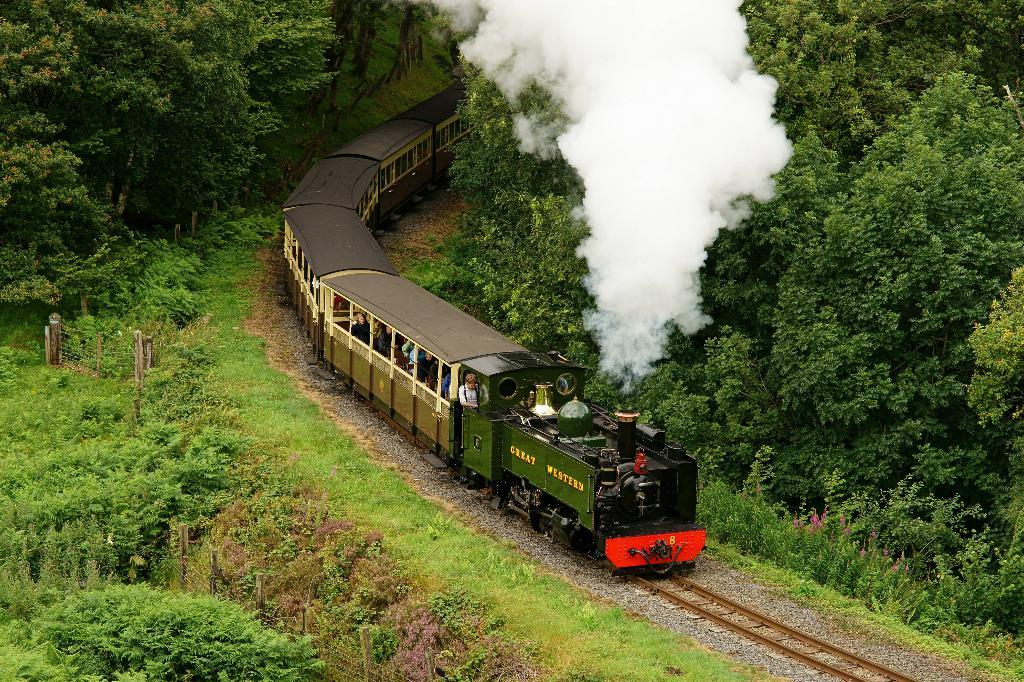What mode of transportation are the people in the image using? The people are in a train. What is the train situated on? The train is on a track. What type of terrain can be seen in the image? There are stones, grass, and plants visible in the image. What type of barrier is present in the image? There is a fence in the image. What type of vegetation is present in the image? There is a group of trees in the image. What is the indication of the train's activity in the image? There is smoke visible in the image. What type of zipper can be seen on the train in the image? There is no zipper present on the train in the image. What grade level is the train traveling on in the image? The image does not provide information about the train's grade level. 